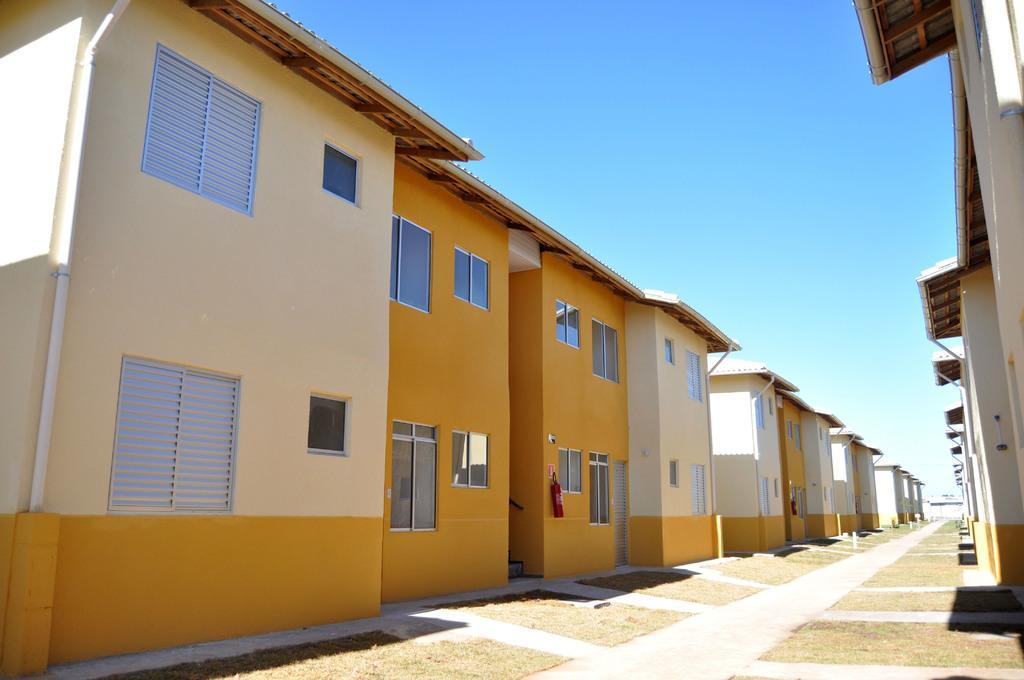Can you describe this image briefly? As we can see in the image there are few houses on the right side and left side with orange and cream color. In the middle of the houses there is a road. 